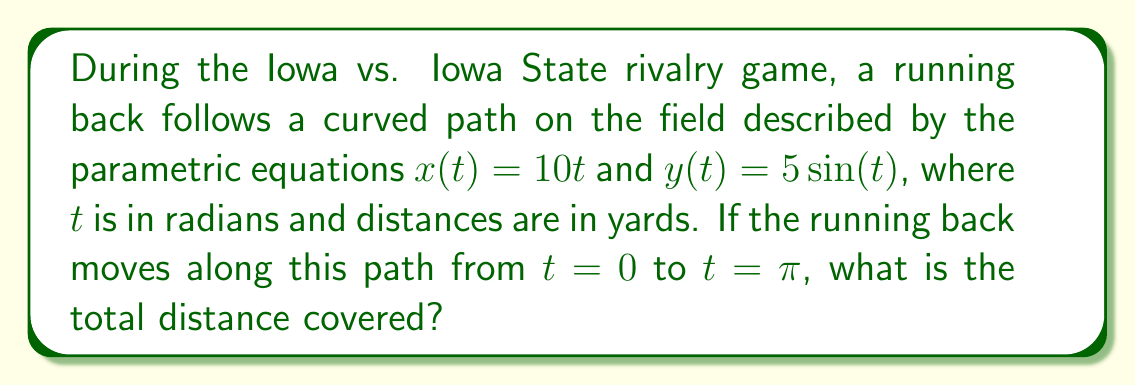Can you solve this math problem? To find the total distance covered by the running back, we need to use a path integral. The steps are as follows:

1) The path integral for distance is given by:
   $$\int_a^b \sqrt{\left(\frac{dx}{dt}\right)^2 + \left(\frac{dy}{dt}\right)^2} dt$$

2) Calculate $\frac{dx}{dt}$ and $\frac{dy}{dt}$:
   $\frac{dx}{dt} = 10$
   $\frac{dy}{dt} = 5\cos(t)$

3) Substitute these into the path integral:
   $$\int_0^\pi \sqrt{10^2 + (5\cos(t))^2} dt$$

4) Simplify under the square root:
   $$\int_0^\pi \sqrt{100 + 25\cos^2(t)} dt$$

5) This integral doesn't have an elementary antiderivative, so we need to evaluate it numerically. Using a computer algebra system or numerical integration method, we can find that the value of this integral is approximately 33.85 yards.
Answer: 33.85 yards 